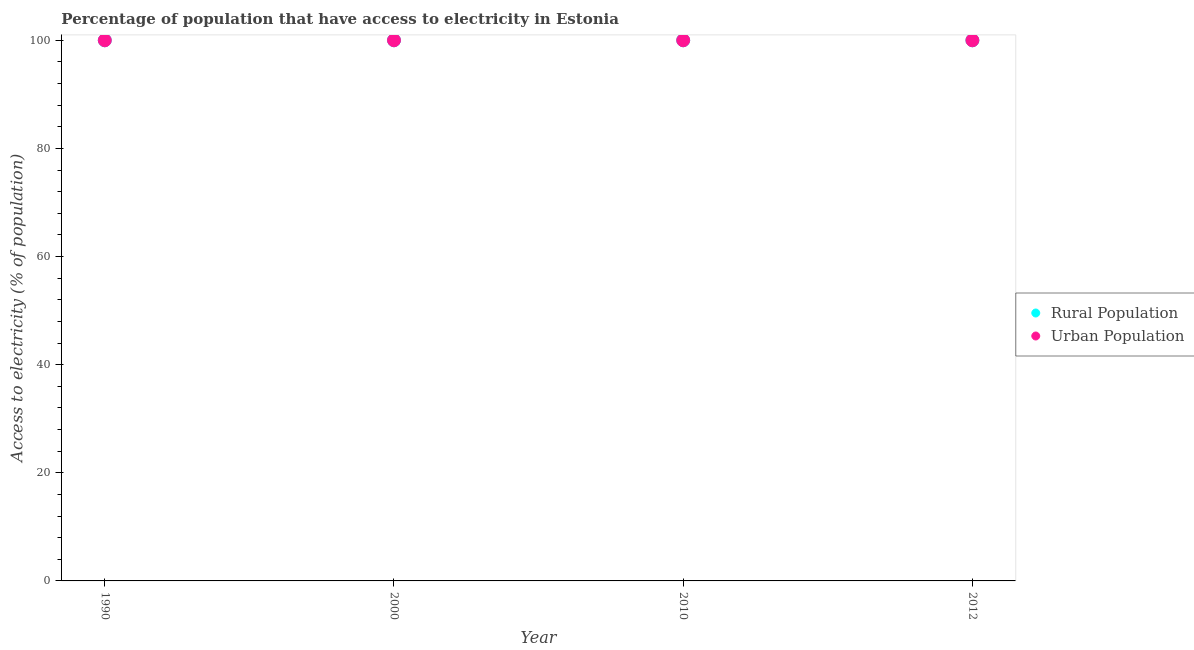How many different coloured dotlines are there?
Give a very brief answer. 2. Is the number of dotlines equal to the number of legend labels?
Your answer should be compact. Yes. What is the percentage of urban population having access to electricity in 2000?
Your answer should be very brief. 100. Across all years, what is the maximum percentage of urban population having access to electricity?
Offer a terse response. 100. Across all years, what is the minimum percentage of urban population having access to electricity?
Give a very brief answer. 100. In which year was the percentage of urban population having access to electricity maximum?
Offer a terse response. 1990. In which year was the percentage of urban population having access to electricity minimum?
Offer a terse response. 1990. What is the total percentage of urban population having access to electricity in the graph?
Your answer should be very brief. 400. What is the difference between the percentage of rural population having access to electricity in 2010 and the percentage of urban population having access to electricity in 2012?
Offer a terse response. 0. In the year 2010, what is the difference between the percentage of rural population having access to electricity and percentage of urban population having access to electricity?
Your response must be concise. 0. In how many years, is the percentage of rural population having access to electricity greater than 64 %?
Your answer should be compact. 4. What is the ratio of the percentage of rural population having access to electricity in 2000 to that in 2010?
Your answer should be very brief. 1. Is the percentage of rural population having access to electricity in 2000 less than that in 2010?
Make the answer very short. No. What is the difference between the highest and the lowest percentage of urban population having access to electricity?
Your answer should be very brief. 0. Is the sum of the percentage of urban population having access to electricity in 1990 and 2000 greater than the maximum percentage of rural population having access to electricity across all years?
Your response must be concise. Yes. Does the percentage of rural population having access to electricity monotonically increase over the years?
Keep it short and to the point. No. Is the percentage of rural population having access to electricity strictly less than the percentage of urban population having access to electricity over the years?
Ensure brevity in your answer.  No. How many years are there in the graph?
Offer a terse response. 4. Does the graph contain any zero values?
Provide a succinct answer. No. Where does the legend appear in the graph?
Make the answer very short. Center right. How are the legend labels stacked?
Offer a very short reply. Vertical. What is the title of the graph?
Offer a terse response. Percentage of population that have access to electricity in Estonia. What is the label or title of the Y-axis?
Your answer should be compact. Access to electricity (% of population). What is the Access to electricity (% of population) of Rural Population in 2010?
Your response must be concise. 100. What is the Access to electricity (% of population) in Urban Population in 2010?
Keep it short and to the point. 100. What is the Access to electricity (% of population) of Rural Population in 2012?
Offer a terse response. 100. What is the Access to electricity (% of population) of Urban Population in 2012?
Your answer should be very brief. 100. Across all years, what is the maximum Access to electricity (% of population) in Rural Population?
Give a very brief answer. 100. Across all years, what is the minimum Access to electricity (% of population) in Rural Population?
Your answer should be compact. 100. What is the difference between the Access to electricity (% of population) in Urban Population in 1990 and that in 2012?
Keep it short and to the point. 0. What is the difference between the Access to electricity (% of population) of Rural Population in 2000 and that in 2010?
Your answer should be very brief. 0. What is the difference between the Access to electricity (% of population) of Urban Population in 2000 and that in 2010?
Give a very brief answer. 0. What is the difference between the Access to electricity (% of population) in Rural Population in 2000 and that in 2012?
Give a very brief answer. 0. What is the difference between the Access to electricity (% of population) of Rural Population in 1990 and the Access to electricity (% of population) of Urban Population in 2000?
Ensure brevity in your answer.  0. What is the difference between the Access to electricity (% of population) in Rural Population in 2000 and the Access to electricity (% of population) in Urban Population in 2012?
Provide a succinct answer. 0. What is the difference between the Access to electricity (% of population) of Rural Population in 2010 and the Access to electricity (% of population) of Urban Population in 2012?
Provide a short and direct response. 0. What is the average Access to electricity (% of population) of Rural Population per year?
Provide a short and direct response. 100. What is the average Access to electricity (% of population) in Urban Population per year?
Your answer should be compact. 100. In the year 1990, what is the difference between the Access to electricity (% of population) in Rural Population and Access to electricity (% of population) in Urban Population?
Provide a succinct answer. 0. In the year 2000, what is the difference between the Access to electricity (% of population) in Rural Population and Access to electricity (% of population) in Urban Population?
Your response must be concise. 0. In the year 2010, what is the difference between the Access to electricity (% of population) of Rural Population and Access to electricity (% of population) of Urban Population?
Give a very brief answer. 0. In the year 2012, what is the difference between the Access to electricity (% of population) in Rural Population and Access to electricity (% of population) in Urban Population?
Ensure brevity in your answer.  0. What is the ratio of the Access to electricity (% of population) in Rural Population in 1990 to that in 2000?
Offer a terse response. 1. What is the ratio of the Access to electricity (% of population) of Urban Population in 1990 to that in 2000?
Your answer should be compact. 1. What is the ratio of the Access to electricity (% of population) in Urban Population in 1990 to that in 2010?
Make the answer very short. 1. What is the ratio of the Access to electricity (% of population) of Rural Population in 1990 to that in 2012?
Provide a succinct answer. 1. What is the ratio of the Access to electricity (% of population) in Rural Population in 2000 to that in 2010?
Your answer should be compact. 1. What is the ratio of the Access to electricity (% of population) in Rural Population in 2000 to that in 2012?
Offer a terse response. 1. What is the ratio of the Access to electricity (% of population) in Urban Population in 2000 to that in 2012?
Make the answer very short. 1. What is the ratio of the Access to electricity (% of population) of Rural Population in 2010 to that in 2012?
Your response must be concise. 1. What is the ratio of the Access to electricity (% of population) of Urban Population in 2010 to that in 2012?
Provide a short and direct response. 1. What is the difference between the highest and the lowest Access to electricity (% of population) in Urban Population?
Provide a succinct answer. 0. 